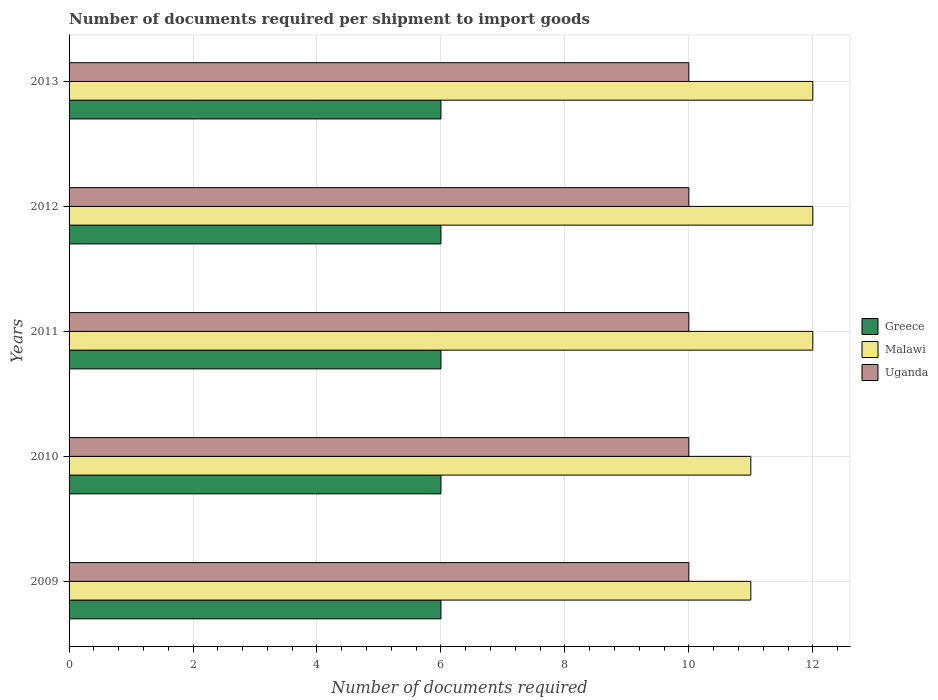How many different coloured bars are there?
Provide a succinct answer. 3. Are the number of bars on each tick of the Y-axis equal?
Offer a terse response. Yes. How many bars are there on the 3rd tick from the bottom?
Your answer should be compact. 3. What is the number of documents required per shipment to import goods in Uganda in 2012?
Provide a short and direct response. 10. Across all years, what is the maximum number of documents required per shipment to import goods in Uganda?
Give a very brief answer. 10. In which year was the number of documents required per shipment to import goods in Uganda minimum?
Give a very brief answer. 2009. What is the total number of documents required per shipment to import goods in Uganda in the graph?
Keep it short and to the point. 50. What is the difference between the number of documents required per shipment to import goods in Malawi in 2010 and that in 2011?
Offer a very short reply. -1. What is the difference between the number of documents required per shipment to import goods in Greece in 2010 and the number of documents required per shipment to import goods in Uganda in 2012?
Make the answer very short. -4. What is the ratio of the number of documents required per shipment to import goods in Malawi in 2010 to that in 2012?
Your response must be concise. 0.92. Is the difference between the number of documents required per shipment to import goods in Malawi in 2010 and 2011 greater than the difference between the number of documents required per shipment to import goods in Greece in 2010 and 2011?
Your answer should be compact. No. What is the difference between the highest and the second highest number of documents required per shipment to import goods in Uganda?
Your answer should be very brief. 0. What is the difference between the highest and the lowest number of documents required per shipment to import goods in Malawi?
Your response must be concise. 1. What does the 1st bar from the top in 2009 represents?
Offer a terse response. Uganda. What does the 2nd bar from the bottom in 2011 represents?
Keep it short and to the point. Malawi. Is it the case that in every year, the sum of the number of documents required per shipment to import goods in Greece and number of documents required per shipment to import goods in Malawi is greater than the number of documents required per shipment to import goods in Uganda?
Your answer should be compact. Yes. Are all the bars in the graph horizontal?
Your response must be concise. Yes. How many years are there in the graph?
Give a very brief answer. 5. Does the graph contain grids?
Give a very brief answer. Yes. How many legend labels are there?
Provide a succinct answer. 3. How are the legend labels stacked?
Offer a terse response. Vertical. What is the title of the graph?
Make the answer very short. Number of documents required per shipment to import goods. What is the label or title of the X-axis?
Offer a terse response. Number of documents required. What is the Number of documents required of Malawi in 2009?
Make the answer very short. 11. What is the Number of documents required of Uganda in 2009?
Ensure brevity in your answer.  10. What is the Number of documents required of Greece in 2010?
Keep it short and to the point. 6. What is the Number of documents required in Greece in 2011?
Ensure brevity in your answer.  6. What is the Number of documents required in Greece in 2012?
Make the answer very short. 6. Across all years, what is the maximum Number of documents required of Malawi?
Your response must be concise. 12. Across all years, what is the minimum Number of documents required in Greece?
Keep it short and to the point. 6. Across all years, what is the minimum Number of documents required in Malawi?
Keep it short and to the point. 11. What is the total Number of documents required of Greece in the graph?
Make the answer very short. 30. What is the total Number of documents required in Malawi in the graph?
Make the answer very short. 58. What is the difference between the Number of documents required in Greece in 2009 and that in 2010?
Offer a very short reply. 0. What is the difference between the Number of documents required of Malawi in 2009 and that in 2010?
Give a very brief answer. 0. What is the difference between the Number of documents required in Greece in 2009 and that in 2011?
Your answer should be very brief. 0. What is the difference between the Number of documents required in Uganda in 2009 and that in 2011?
Make the answer very short. 0. What is the difference between the Number of documents required of Uganda in 2009 and that in 2012?
Keep it short and to the point. 0. What is the difference between the Number of documents required in Greece in 2009 and that in 2013?
Offer a terse response. 0. What is the difference between the Number of documents required of Malawi in 2009 and that in 2013?
Offer a very short reply. -1. What is the difference between the Number of documents required of Greece in 2010 and that in 2011?
Your response must be concise. 0. What is the difference between the Number of documents required of Malawi in 2010 and that in 2011?
Your answer should be very brief. -1. What is the difference between the Number of documents required in Greece in 2010 and that in 2012?
Give a very brief answer. 0. What is the difference between the Number of documents required of Malawi in 2010 and that in 2012?
Your response must be concise. -1. What is the difference between the Number of documents required in Uganda in 2010 and that in 2012?
Provide a succinct answer. 0. What is the difference between the Number of documents required in Greece in 2010 and that in 2013?
Your answer should be very brief. 0. What is the difference between the Number of documents required of Uganda in 2010 and that in 2013?
Your response must be concise. 0. What is the difference between the Number of documents required of Uganda in 2011 and that in 2012?
Your answer should be compact. 0. What is the difference between the Number of documents required in Malawi in 2011 and that in 2013?
Make the answer very short. 0. What is the difference between the Number of documents required in Uganda in 2011 and that in 2013?
Your answer should be compact. 0. What is the difference between the Number of documents required of Greece in 2012 and that in 2013?
Provide a short and direct response. 0. What is the difference between the Number of documents required of Uganda in 2012 and that in 2013?
Keep it short and to the point. 0. What is the difference between the Number of documents required of Greece in 2009 and the Number of documents required of Uganda in 2010?
Make the answer very short. -4. What is the difference between the Number of documents required of Malawi in 2009 and the Number of documents required of Uganda in 2010?
Your answer should be compact. 1. What is the difference between the Number of documents required of Greece in 2009 and the Number of documents required of Malawi in 2011?
Keep it short and to the point. -6. What is the difference between the Number of documents required of Malawi in 2009 and the Number of documents required of Uganda in 2011?
Your response must be concise. 1. What is the difference between the Number of documents required of Greece in 2009 and the Number of documents required of Uganda in 2012?
Offer a terse response. -4. What is the difference between the Number of documents required of Greece in 2009 and the Number of documents required of Malawi in 2013?
Your answer should be very brief. -6. What is the difference between the Number of documents required in Malawi in 2009 and the Number of documents required in Uganda in 2013?
Give a very brief answer. 1. What is the difference between the Number of documents required in Greece in 2010 and the Number of documents required in Uganda in 2012?
Your response must be concise. -4. What is the difference between the Number of documents required in Greece in 2010 and the Number of documents required in Uganda in 2013?
Ensure brevity in your answer.  -4. What is the difference between the Number of documents required of Greece in 2011 and the Number of documents required of Malawi in 2012?
Provide a succinct answer. -6. What is the difference between the Number of documents required of Malawi in 2011 and the Number of documents required of Uganda in 2012?
Ensure brevity in your answer.  2. What is the difference between the Number of documents required of Greece in 2011 and the Number of documents required of Uganda in 2013?
Make the answer very short. -4. What is the difference between the Number of documents required of Malawi in 2011 and the Number of documents required of Uganda in 2013?
Provide a short and direct response. 2. What is the difference between the Number of documents required of Greece in 2012 and the Number of documents required of Malawi in 2013?
Your answer should be very brief. -6. What is the average Number of documents required in Greece per year?
Your answer should be very brief. 6. In the year 2009, what is the difference between the Number of documents required in Greece and Number of documents required in Uganda?
Your response must be concise. -4. In the year 2010, what is the difference between the Number of documents required in Greece and Number of documents required in Malawi?
Give a very brief answer. -5. In the year 2011, what is the difference between the Number of documents required in Greece and Number of documents required in Malawi?
Offer a terse response. -6. In the year 2013, what is the difference between the Number of documents required in Greece and Number of documents required in Malawi?
Give a very brief answer. -6. In the year 2013, what is the difference between the Number of documents required in Malawi and Number of documents required in Uganda?
Your response must be concise. 2. What is the ratio of the Number of documents required of Greece in 2009 to that in 2010?
Provide a succinct answer. 1. What is the ratio of the Number of documents required of Malawi in 2009 to that in 2010?
Keep it short and to the point. 1. What is the ratio of the Number of documents required of Uganda in 2009 to that in 2010?
Keep it short and to the point. 1. What is the ratio of the Number of documents required of Malawi in 2009 to that in 2011?
Your answer should be compact. 0.92. What is the ratio of the Number of documents required in Greece in 2009 to that in 2012?
Provide a short and direct response. 1. What is the ratio of the Number of documents required of Malawi in 2009 to that in 2012?
Ensure brevity in your answer.  0.92. What is the ratio of the Number of documents required of Greece in 2009 to that in 2013?
Provide a short and direct response. 1. What is the ratio of the Number of documents required of Malawi in 2009 to that in 2013?
Keep it short and to the point. 0.92. What is the ratio of the Number of documents required in Uganda in 2009 to that in 2013?
Your response must be concise. 1. What is the ratio of the Number of documents required in Greece in 2010 to that in 2011?
Offer a terse response. 1. What is the ratio of the Number of documents required of Malawi in 2010 to that in 2011?
Keep it short and to the point. 0.92. What is the ratio of the Number of documents required of Uganda in 2010 to that in 2011?
Your answer should be very brief. 1. What is the ratio of the Number of documents required in Greece in 2010 to that in 2012?
Your response must be concise. 1. What is the ratio of the Number of documents required in Malawi in 2010 to that in 2012?
Your answer should be compact. 0.92. What is the ratio of the Number of documents required of Uganda in 2010 to that in 2012?
Keep it short and to the point. 1. What is the ratio of the Number of documents required of Malawi in 2010 to that in 2013?
Offer a terse response. 0.92. What is the ratio of the Number of documents required of Uganda in 2011 to that in 2012?
Your answer should be very brief. 1. What is the ratio of the Number of documents required in Uganda in 2011 to that in 2013?
Your answer should be very brief. 1. What is the ratio of the Number of documents required of Malawi in 2012 to that in 2013?
Offer a very short reply. 1. What is the difference between the highest and the second highest Number of documents required of Greece?
Your response must be concise. 0. What is the difference between the highest and the second highest Number of documents required in Uganda?
Your answer should be very brief. 0. What is the difference between the highest and the lowest Number of documents required of Greece?
Offer a terse response. 0. What is the difference between the highest and the lowest Number of documents required in Uganda?
Keep it short and to the point. 0. 